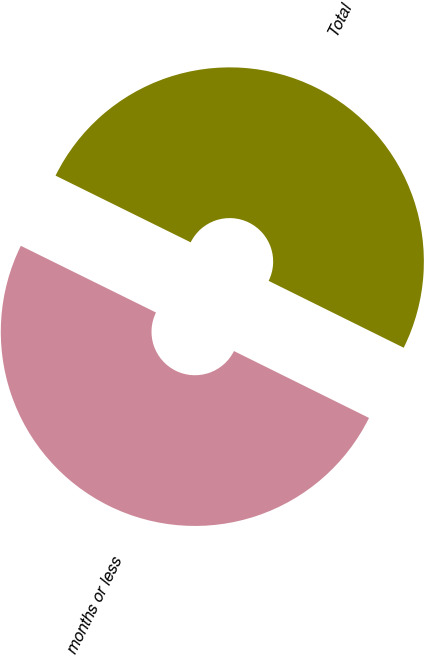<chart> <loc_0><loc_0><loc_500><loc_500><pie_chart><fcel>Three months or less<fcel>Total<nl><fcel>49.98%<fcel>50.02%<nl></chart> 